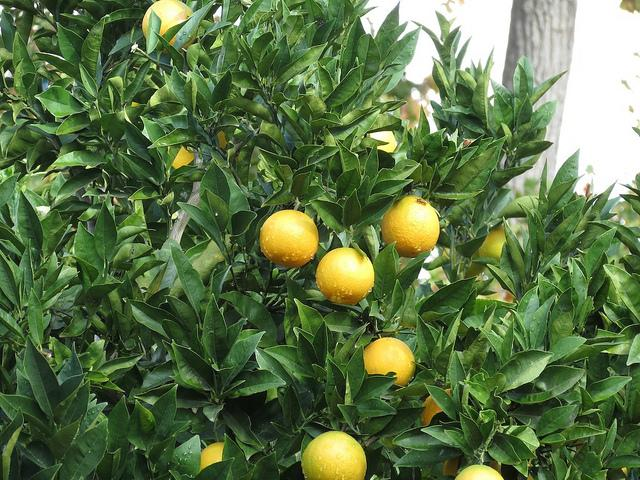What type of fruit is most likely on the tree? lemon 